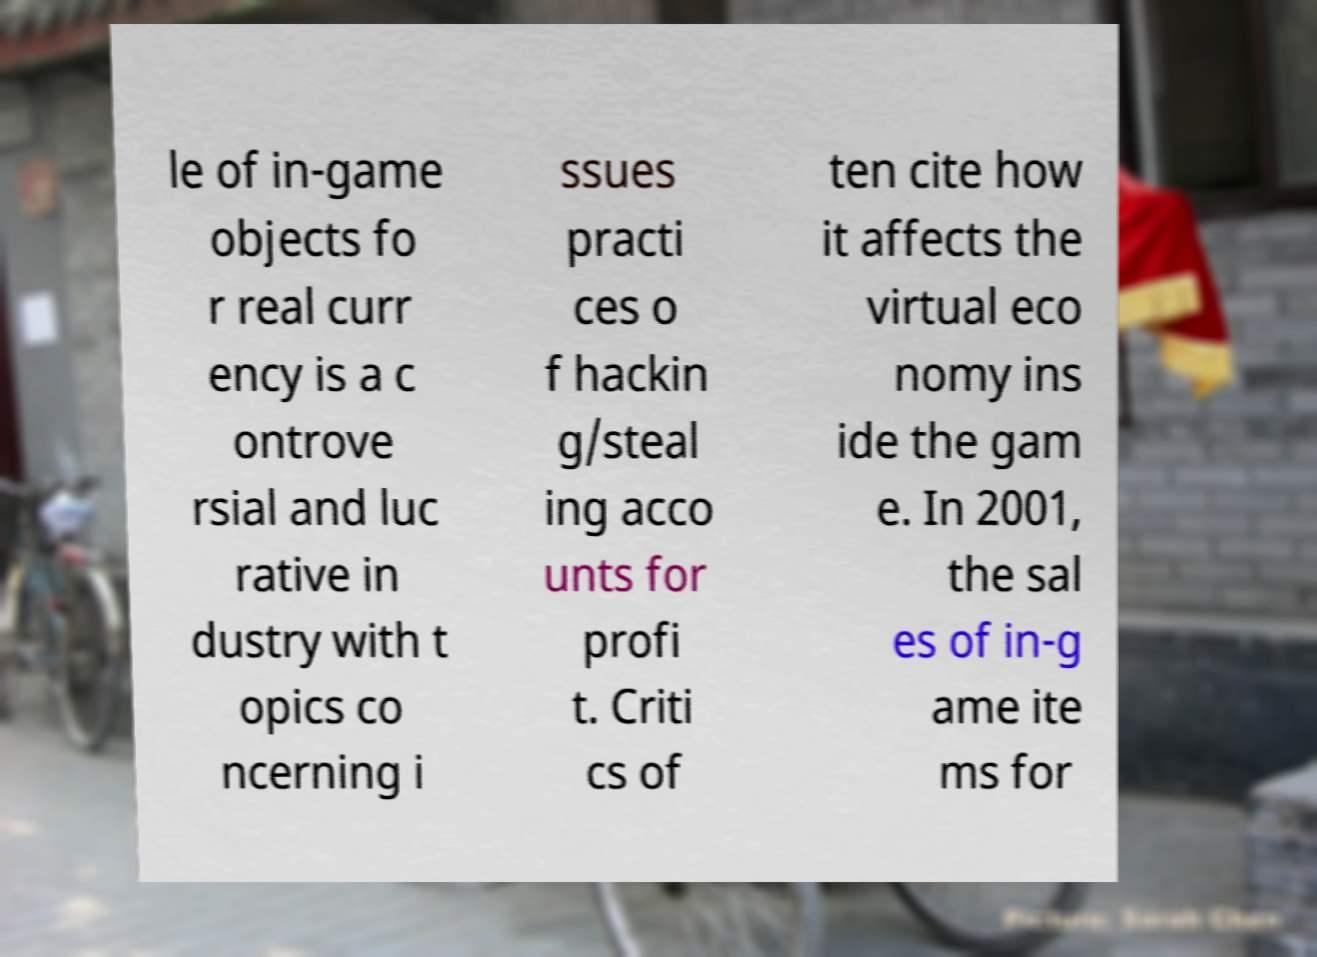There's text embedded in this image that I need extracted. Can you transcribe it verbatim? le of in-game objects fo r real curr ency is a c ontrove rsial and luc rative in dustry with t opics co ncerning i ssues practi ces o f hackin g/steal ing acco unts for profi t. Criti cs of ten cite how it affects the virtual eco nomy ins ide the gam e. In 2001, the sal es of in-g ame ite ms for 